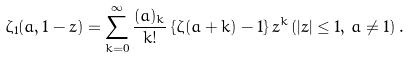Convert formula to latex. <formula><loc_0><loc_0><loc_500><loc_500>\zeta _ { 1 } ( a , 1 - z ) = \sum _ { k = 0 } ^ { \infty } \frac { ( a ) _ { k } } { k ! } \, \{ \zeta ( a + k ) - 1 \} \, z ^ { k } \, ( | z | \leq 1 , \, a \ne 1 ) \, .</formula> 